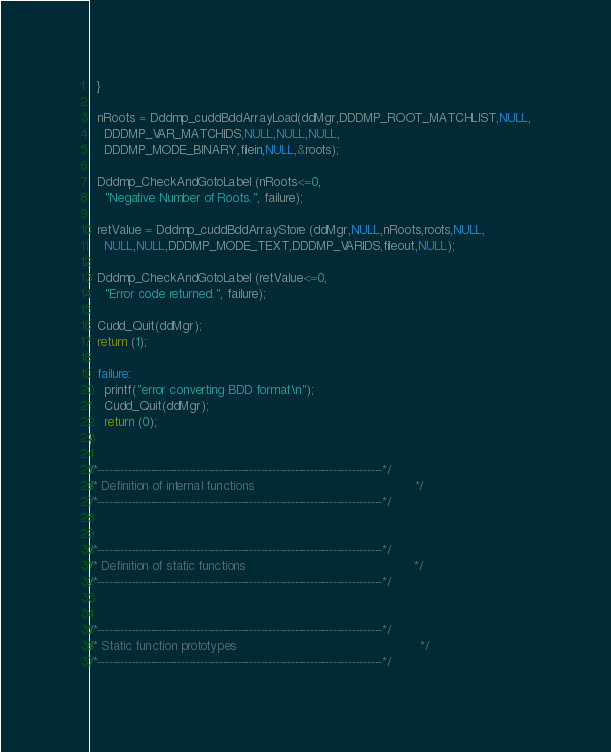<code> <loc_0><loc_0><loc_500><loc_500><_C_>  }

  nRoots = Dddmp_cuddBddArrayLoad(ddMgr,DDDMP_ROOT_MATCHLIST,NULL,
    DDDMP_VAR_MATCHIDS,NULL,NULL,NULL,
    DDDMP_MODE_BINARY,filein,NULL,&roots);

  Dddmp_CheckAndGotoLabel (nRoots<=0,
    "Negative Number of Roots.", failure);

  retValue = Dddmp_cuddBddArrayStore (ddMgr,NULL,nRoots,roots,NULL,
    NULL,NULL,DDDMP_MODE_TEXT,DDDMP_VARIDS,fileout,NULL);

  Dddmp_CheckAndGotoLabel (retValue<=0,
    "Error code returned.", failure);
   
  Cudd_Quit(ddMgr);
  return (1);

  failure:
    printf("error converting BDD format\n");
    Cudd_Quit(ddMgr);
    return (0);
}

/*---------------------------------------------------------------------------*/
/* Definition of internal functions                                          */
/*---------------------------------------------------------------------------*/


/*---------------------------------------------------------------------------*/
/* Definition of static functions                                            */
/*---------------------------------------------------------------------------*/


/*---------------------------------------------------------------------------*/
/* Static function prototypes                                                */
/*---------------------------------------------------------------------------*/


</code> 